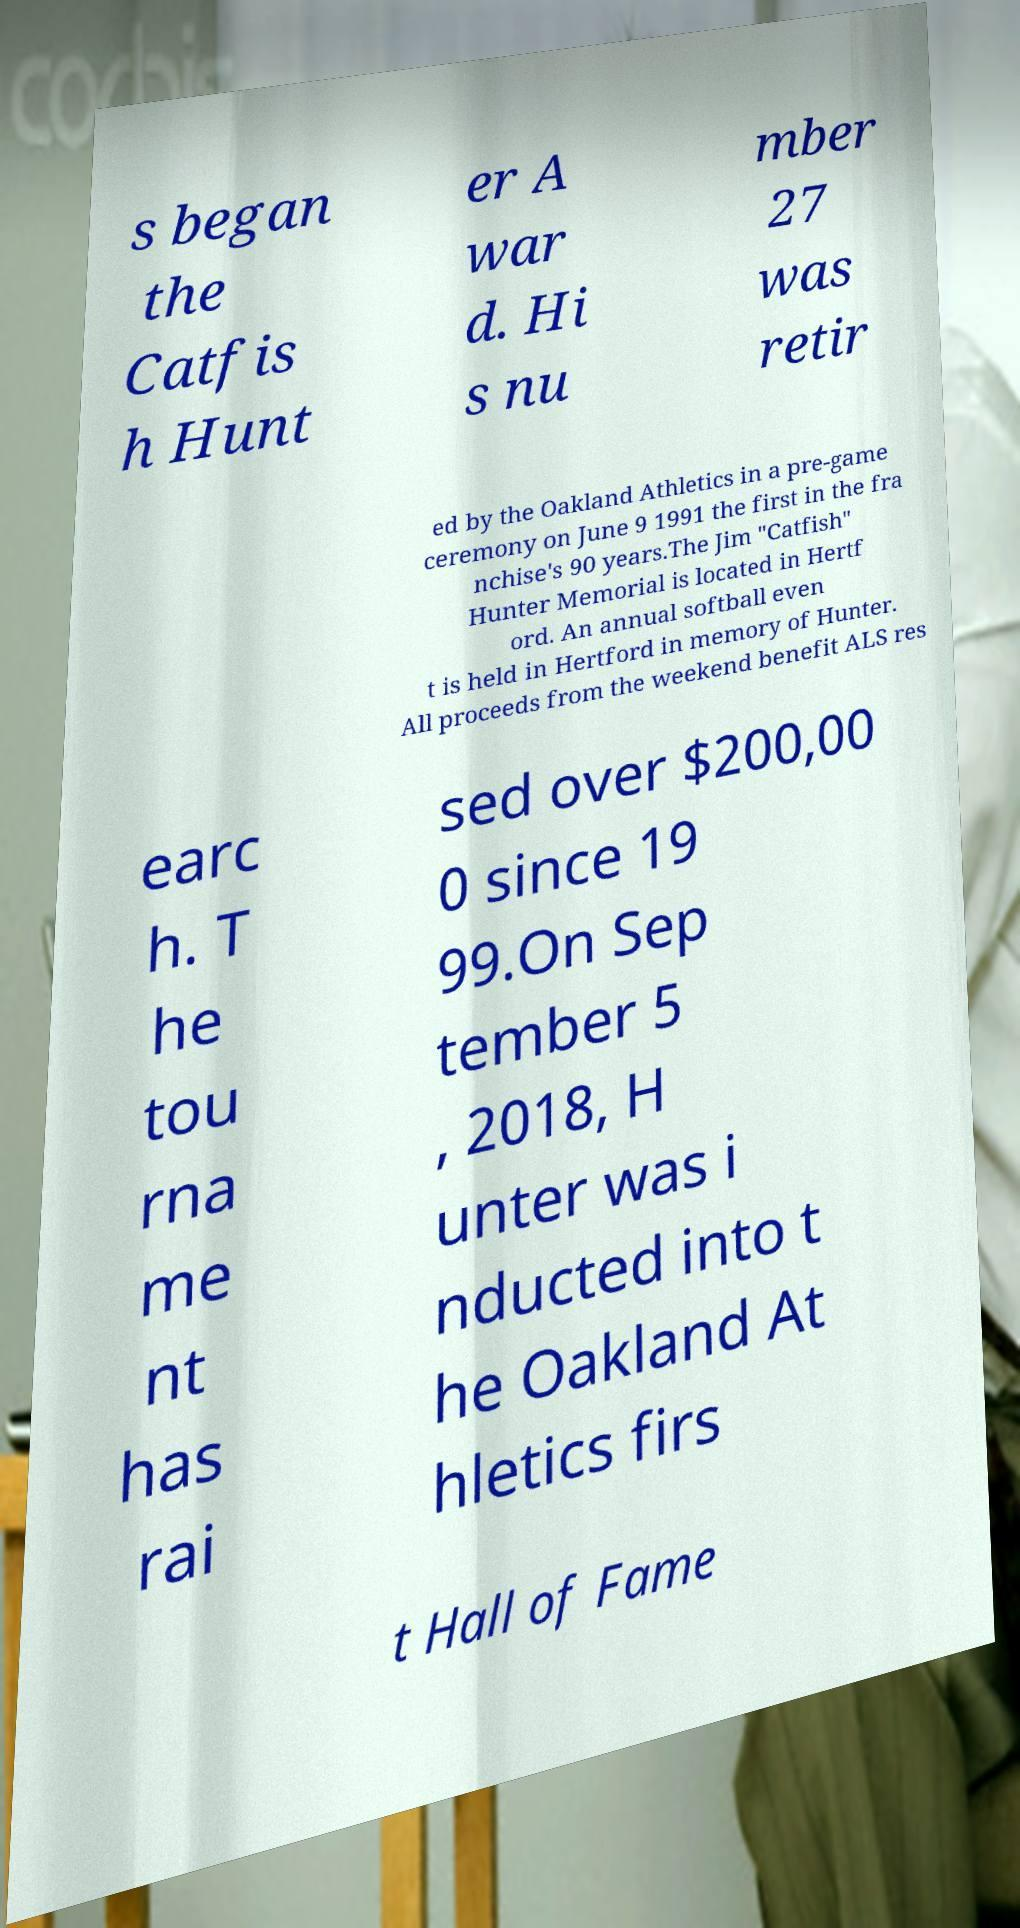Could you assist in decoding the text presented in this image and type it out clearly? s began the Catfis h Hunt er A war d. Hi s nu mber 27 was retir ed by the Oakland Athletics in a pre-game ceremony on June 9 1991 the first in the fra nchise's 90 years.The Jim "Catfish" Hunter Memorial is located in Hertf ord. An annual softball even t is held in Hertford in memory of Hunter. All proceeds from the weekend benefit ALS res earc h. T he tou rna me nt has rai sed over $200,00 0 since 19 99.On Sep tember 5 , 2018, H unter was i nducted into t he Oakland At hletics firs t Hall of Fame 